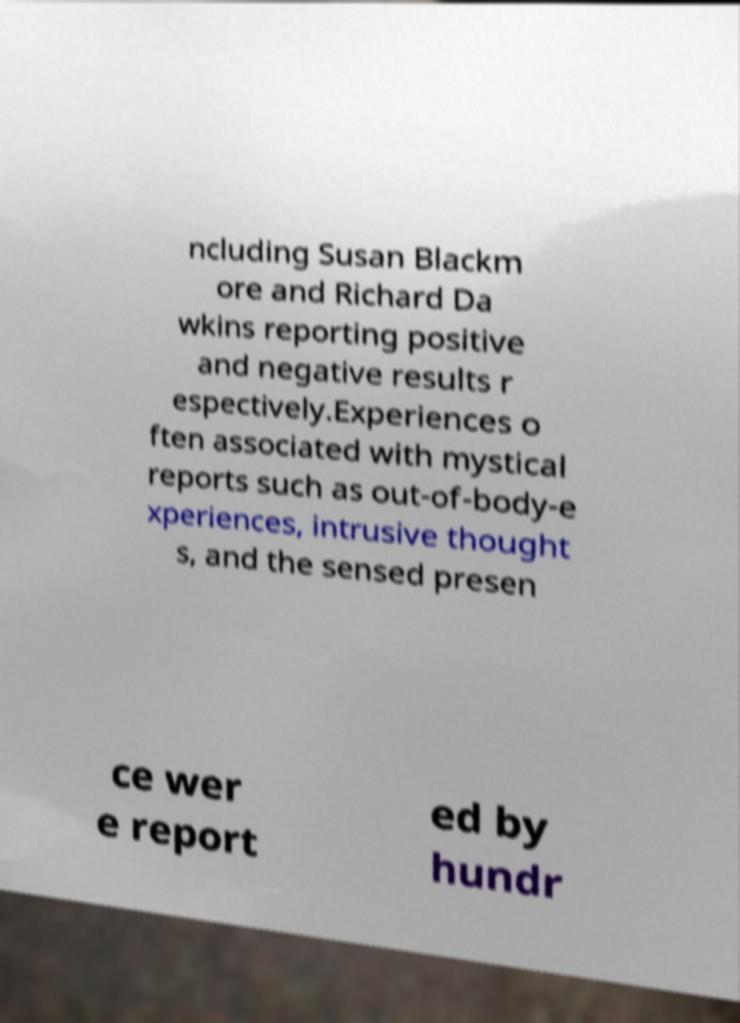For documentation purposes, I need the text within this image transcribed. Could you provide that? ncluding Susan Blackm ore and Richard Da wkins reporting positive and negative results r espectively.Experiences o ften associated with mystical reports such as out-of-body-e xperiences, intrusive thought s, and the sensed presen ce wer e report ed by hundr 